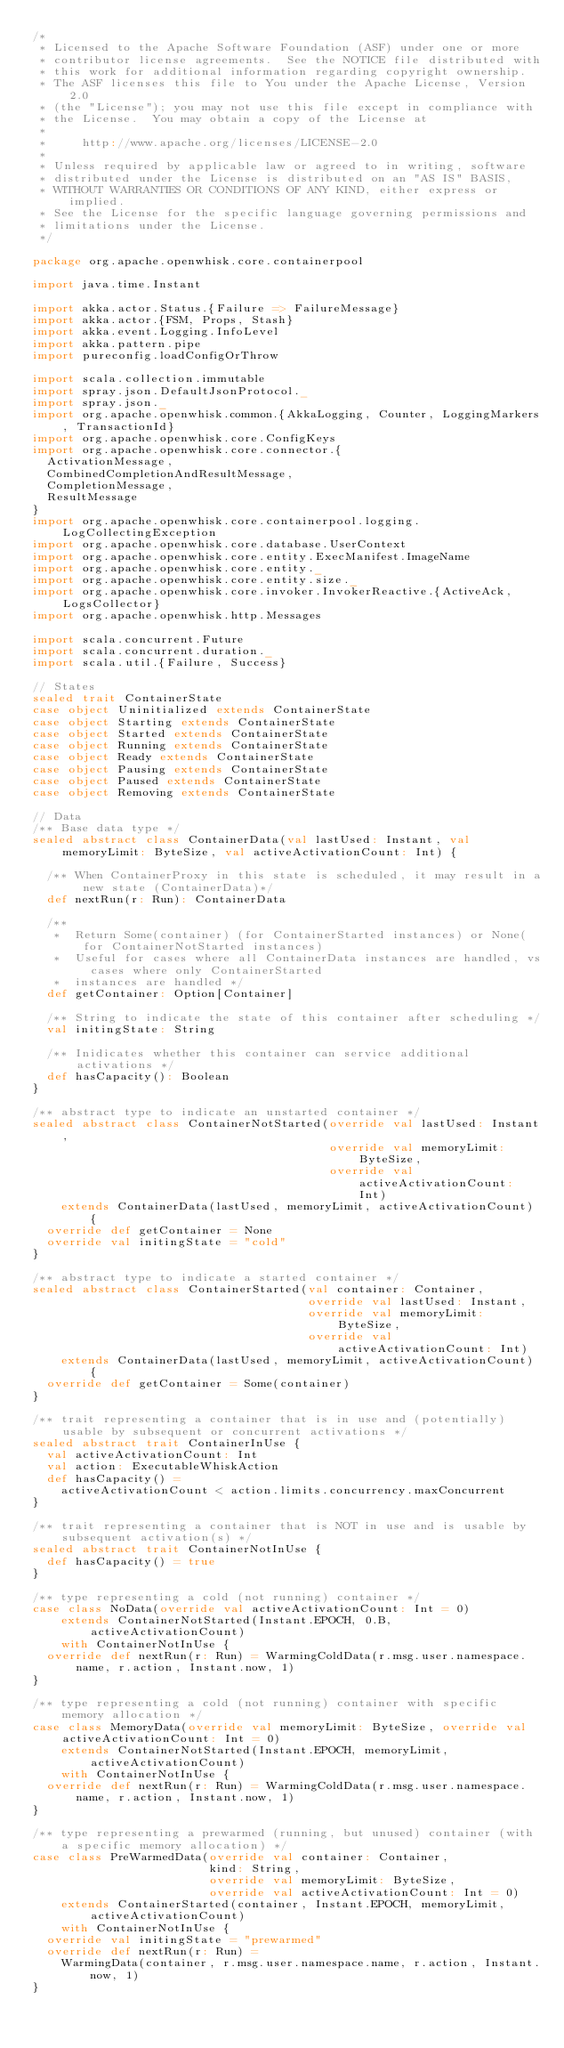Convert code to text. <code><loc_0><loc_0><loc_500><loc_500><_Scala_>/*
 * Licensed to the Apache Software Foundation (ASF) under one or more
 * contributor license agreements.  See the NOTICE file distributed with
 * this work for additional information regarding copyright ownership.
 * The ASF licenses this file to You under the Apache License, Version 2.0
 * (the "License"); you may not use this file except in compliance with
 * the License.  You may obtain a copy of the License at
 *
 *     http://www.apache.org/licenses/LICENSE-2.0
 *
 * Unless required by applicable law or agreed to in writing, software
 * distributed under the License is distributed on an "AS IS" BASIS,
 * WITHOUT WARRANTIES OR CONDITIONS OF ANY KIND, either express or implied.
 * See the License for the specific language governing permissions and
 * limitations under the License.
 */

package org.apache.openwhisk.core.containerpool

import java.time.Instant

import akka.actor.Status.{Failure => FailureMessage}
import akka.actor.{FSM, Props, Stash}
import akka.event.Logging.InfoLevel
import akka.pattern.pipe
import pureconfig.loadConfigOrThrow

import scala.collection.immutable
import spray.json.DefaultJsonProtocol._
import spray.json._
import org.apache.openwhisk.common.{AkkaLogging, Counter, LoggingMarkers, TransactionId}
import org.apache.openwhisk.core.ConfigKeys
import org.apache.openwhisk.core.connector.{
  ActivationMessage,
  CombinedCompletionAndResultMessage,
  CompletionMessage,
  ResultMessage
}
import org.apache.openwhisk.core.containerpool.logging.LogCollectingException
import org.apache.openwhisk.core.database.UserContext
import org.apache.openwhisk.core.entity.ExecManifest.ImageName
import org.apache.openwhisk.core.entity._
import org.apache.openwhisk.core.entity.size._
import org.apache.openwhisk.core.invoker.InvokerReactive.{ActiveAck, LogsCollector}
import org.apache.openwhisk.http.Messages

import scala.concurrent.Future
import scala.concurrent.duration._
import scala.util.{Failure, Success}

// States
sealed trait ContainerState
case object Uninitialized extends ContainerState
case object Starting extends ContainerState
case object Started extends ContainerState
case object Running extends ContainerState
case object Ready extends ContainerState
case object Pausing extends ContainerState
case object Paused extends ContainerState
case object Removing extends ContainerState

// Data
/** Base data type */
sealed abstract class ContainerData(val lastUsed: Instant, val memoryLimit: ByteSize, val activeActivationCount: Int) {

  /** When ContainerProxy in this state is scheduled, it may result in a new state (ContainerData)*/
  def nextRun(r: Run): ContainerData

  /**
   *  Return Some(container) (for ContainerStarted instances) or None(for ContainerNotStarted instances)
   *  Useful for cases where all ContainerData instances are handled, vs cases where only ContainerStarted
   *  instances are handled */
  def getContainer: Option[Container]

  /** String to indicate the state of this container after scheduling */
  val initingState: String

  /** Inidicates whether this container can service additional activations */
  def hasCapacity(): Boolean
}

/** abstract type to indicate an unstarted container */
sealed abstract class ContainerNotStarted(override val lastUsed: Instant,
                                          override val memoryLimit: ByteSize,
                                          override val activeActivationCount: Int)
    extends ContainerData(lastUsed, memoryLimit, activeActivationCount) {
  override def getContainer = None
  override val initingState = "cold"
}

/** abstract type to indicate a started container */
sealed abstract class ContainerStarted(val container: Container,
                                       override val lastUsed: Instant,
                                       override val memoryLimit: ByteSize,
                                       override val activeActivationCount: Int)
    extends ContainerData(lastUsed, memoryLimit, activeActivationCount) {
  override def getContainer = Some(container)
}

/** trait representing a container that is in use and (potentially) usable by subsequent or concurrent activations */
sealed abstract trait ContainerInUse {
  val activeActivationCount: Int
  val action: ExecutableWhiskAction
  def hasCapacity() =
    activeActivationCount < action.limits.concurrency.maxConcurrent
}

/** trait representing a container that is NOT in use and is usable by subsequent activation(s) */
sealed abstract trait ContainerNotInUse {
  def hasCapacity() = true
}

/** type representing a cold (not running) container */
case class NoData(override val activeActivationCount: Int = 0)
    extends ContainerNotStarted(Instant.EPOCH, 0.B, activeActivationCount)
    with ContainerNotInUse {
  override def nextRun(r: Run) = WarmingColdData(r.msg.user.namespace.name, r.action, Instant.now, 1)
}

/** type representing a cold (not running) container with specific memory allocation */
case class MemoryData(override val memoryLimit: ByteSize, override val activeActivationCount: Int = 0)
    extends ContainerNotStarted(Instant.EPOCH, memoryLimit, activeActivationCount)
    with ContainerNotInUse {
  override def nextRun(r: Run) = WarmingColdData(r.msg.user.namespace.name, r.action, Instant.now, 1)
}

/** type representing a prewarmed (running, but unused) container (with a specific memory allocation) */
case class PreWarmedData(override val container: Container,
                         kind: String,
                         override val memoryLimit: ByteSize,
                         override val activeActivationCount: Int = 0)
    extends ContainerStarted(container, Instant.EPOCH, memoryLimit, activeActivationCount)
    with ContainerNotInUse {
  override val initingState = "prewarmed"
  override def nextRun(r: Run) =
    WarmingData(container, r.msg.user.namespace.name, r.action, Instant.now, 1)
}
</code> 